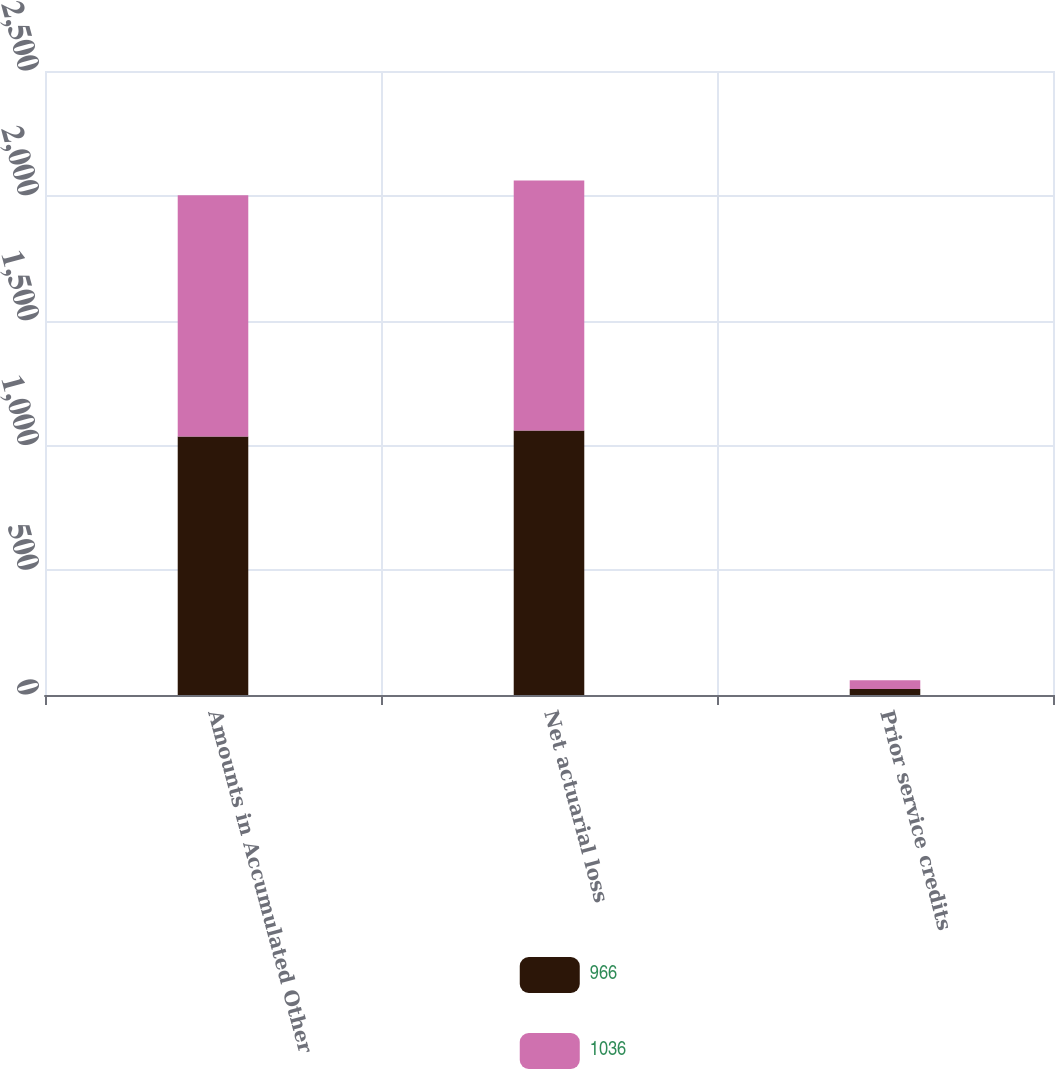Convert chart. <chart><loc_0><loc_0><loc_500><loc_500><stacked_bar_chart><ecel><fcel>Amounts in Accumulated Other<fcel>Net actuarial loss<fcel>Prior service credits<nl><fcel>966<fcel>1036<fcel>1060<fcel>24<nl><fcel>1036<fcel>966<fcel>1001<fcel>35<nl></chart> 